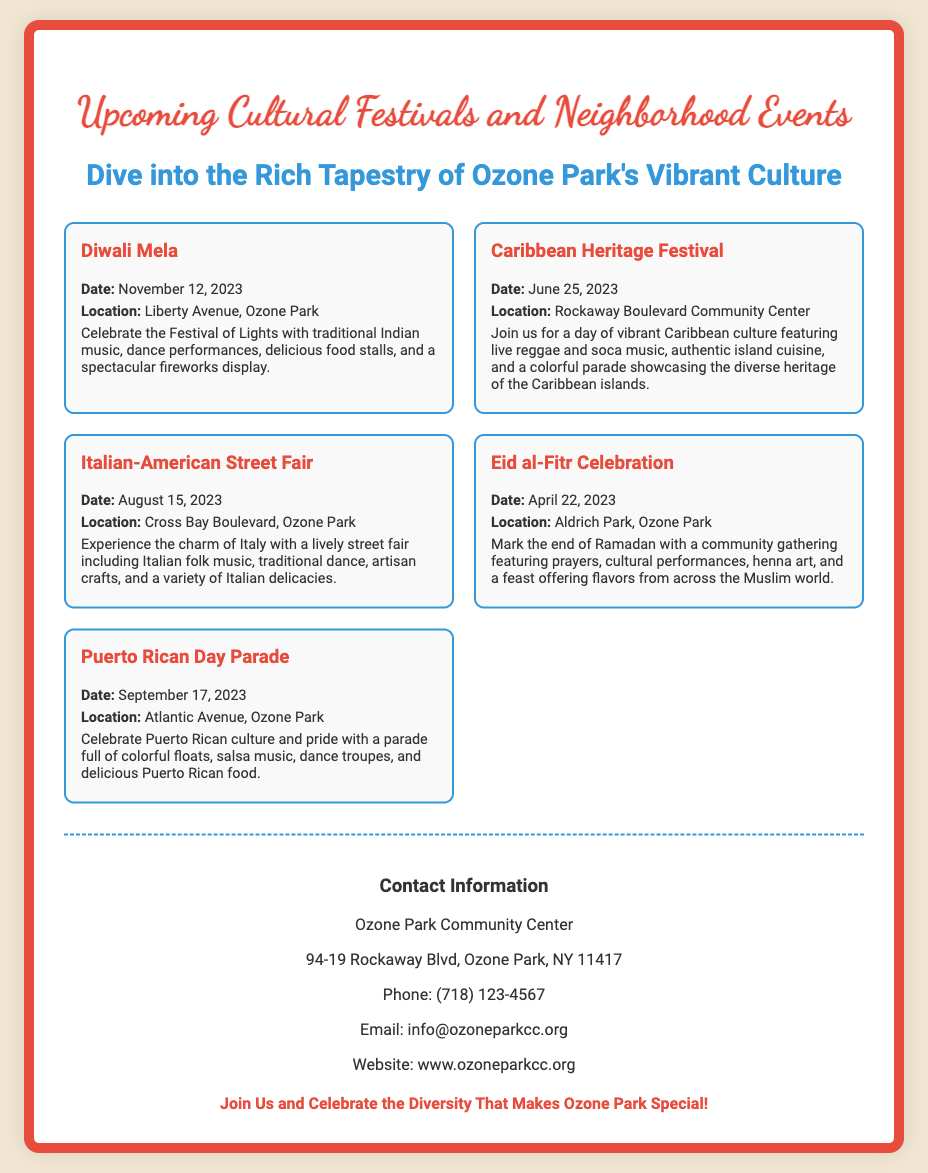What is the date of the Diwali Mela? The document specifies that the Diwali Mela will take place on November 12, 2023.
Answer: November 12, 2023 Where is the Caribbean Heritage Festival being held? According to the document, the Caribbean Heritage Festival is located at the Rockaway Boulevard Community Center.
Answer: Rockaway Boulevard Community Center What cultural aspects are celebrated at the Italian-American Street Fair? The fair includes Italian folk music, traditional dance, artisan crafts, and a variety of Italian delicacies, showcasing Italian culture.
Answer: Italian culture What event marks the end of Ramadan? The document states that the Eid al-Fitr Celebration marks the end of Ramadan.
Answer: Eid al-Fitr Celebration Which event features a colorful parade? The document mentions that the Puerto Rican Day Parade features a colorful parade.
Answer: Puerto Rican Day Parade What is the contact email for the Ozone Park Community Center? The document provides the contact email as info@ozoneparkcc.org.
Answer: info@ozoneparkcc.org Which festival is celebrated on April 22, 2023? The Eid al-Fitr Celebration is scheduled for April 22, 2023, according to the document.
Answer: Eid al-Fitr Celebration How many events are listed in the poster? The document lists a total of five cultural events.
Answer: Five 